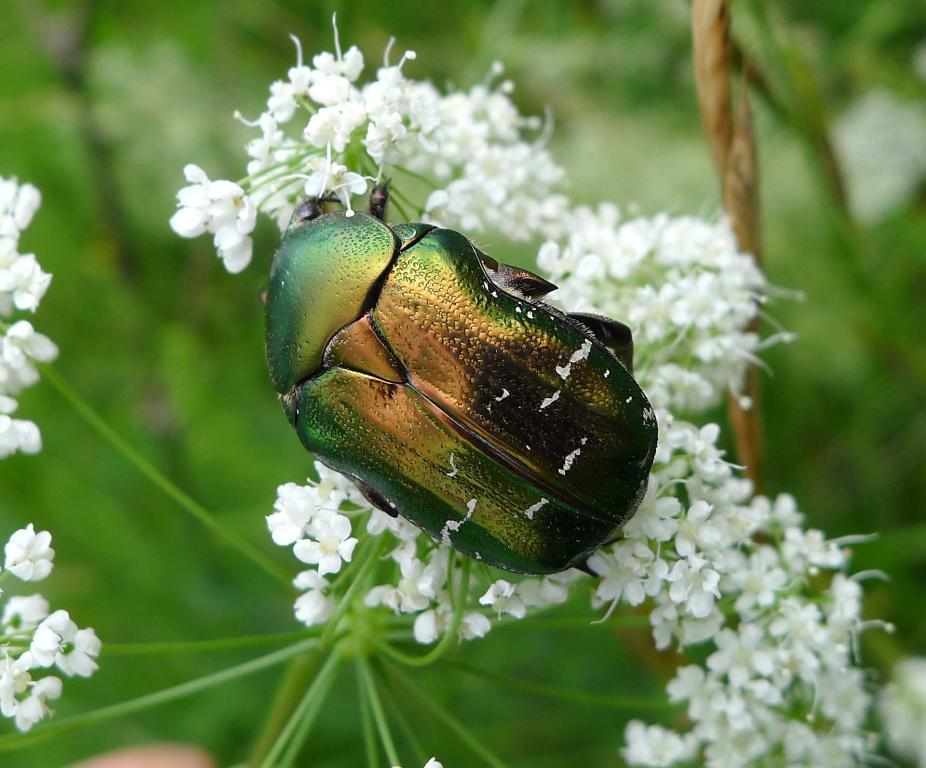What is in the foreground of the image? There is an insect in the foreground of the image. What is the insect sitting on? The insect is on white color flowers. What can be seen in the background of the image? There are flowers and a stem visible in the background of the image. What type of plant is present in the background? The plant is present in the background of the image. How many houses can be seen in the image? There are no houses present in the image; it features an insect on white color flowers with a background of more flowers and a stem. Is there a basketball visible in the image? There is no basketball present in the image. 